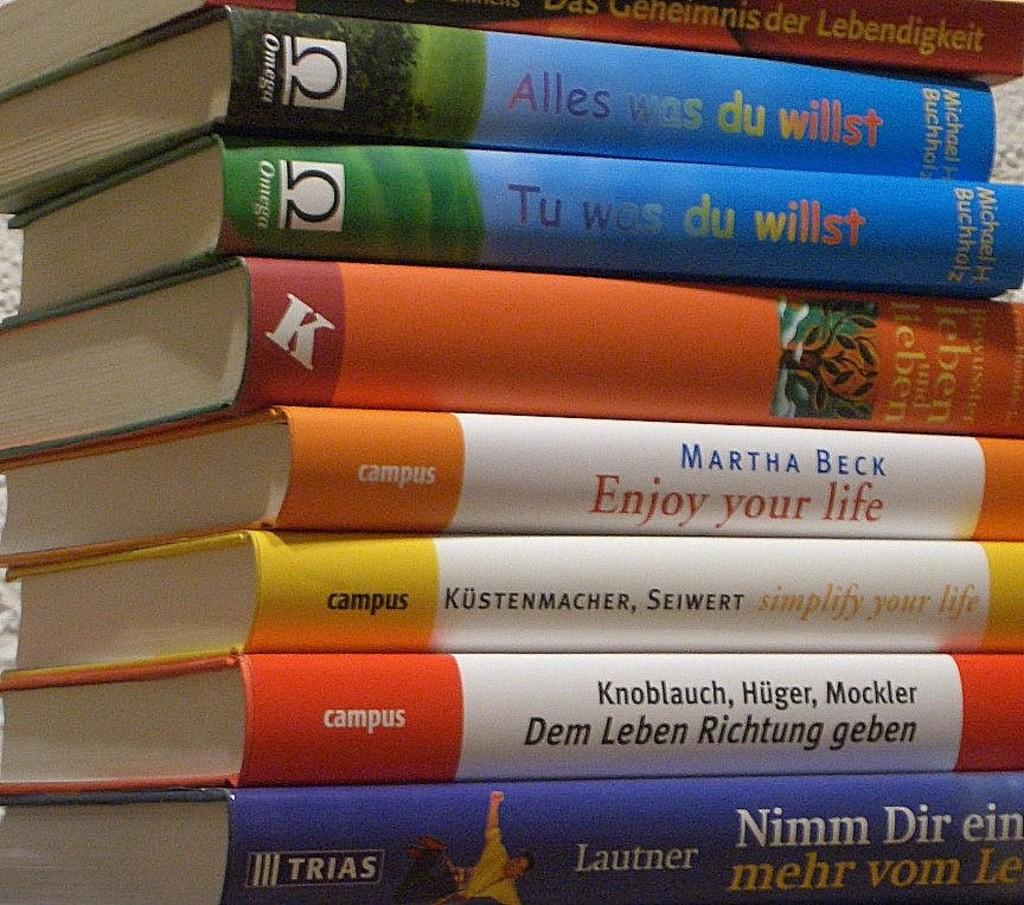<image>
Offer a succinct explanation of the picture presented. A pile of books, the top two are called Alles Was Du Willst. 